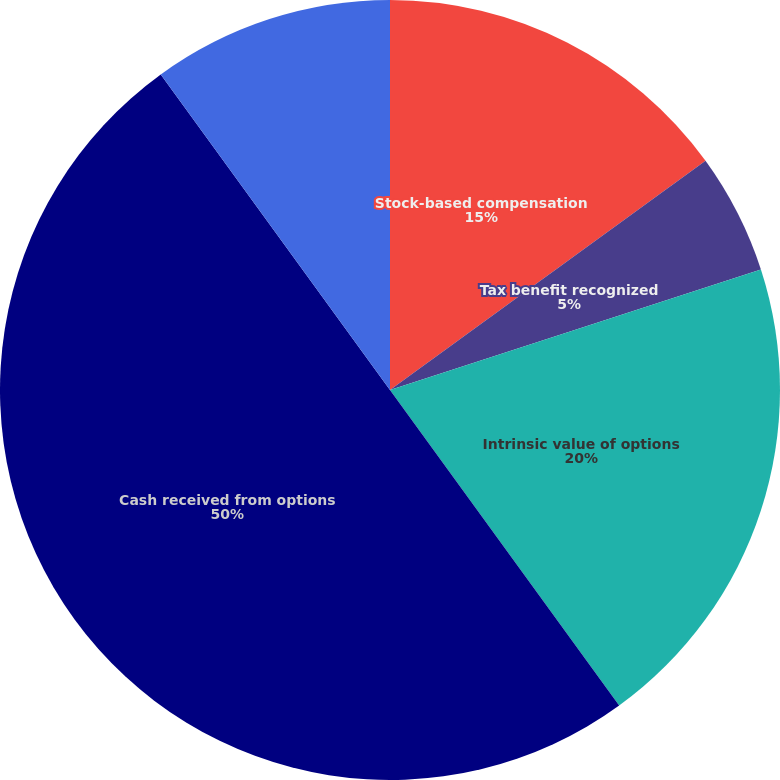Convert chart to OTSL. <chart><loc_0><loc_0><loc_500><loc_500><pie_chart><fcel>Stock-based compensation<fcel>Tax benefit recognized<fcel>Weighted-average grant-date<fcel>Intrinsic value of options<fcel>Cash received from options<fcel>Actual tax benefit received<nl><fcel>15.0%<fcel>5.0%<fcel>0.0%<fcel>20.0%<fcel>49.99%<fcel>10.0%<nl></chart> 